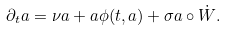Convert formula to latex. <formula><loc_0><loc_0><loc_500><loc_500>\partial _ { t } a = \nu a + a \phi ( t , a ) + \sigma a \circ \dot { W } .</formula> 